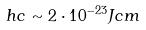Convert formula to latex. <formula><loc_0><loc_0><loc_500><loc_500>h c \sim 2 \cdot 1 0 ^ { - 2 3 } J c m</formula> 